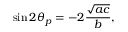<formula> <loc_0><loc_0><loc_500><loc_500>\sin 2 \theta _ { p } = - 2 { \frac { \sqrt { a c } } { b } } ,</formula> 